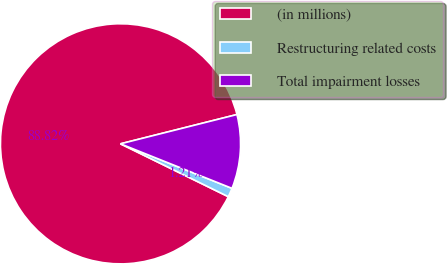<chart> <loc_0><loc_0><loc_500><loc_500><pie_chart><fcel>(in millions)<fcel>Restructuring related costs<fcel>Total impairment losses<nl><fcel>88.83%<fcel>1.21%<fcel>9.97%<nl></chart> 